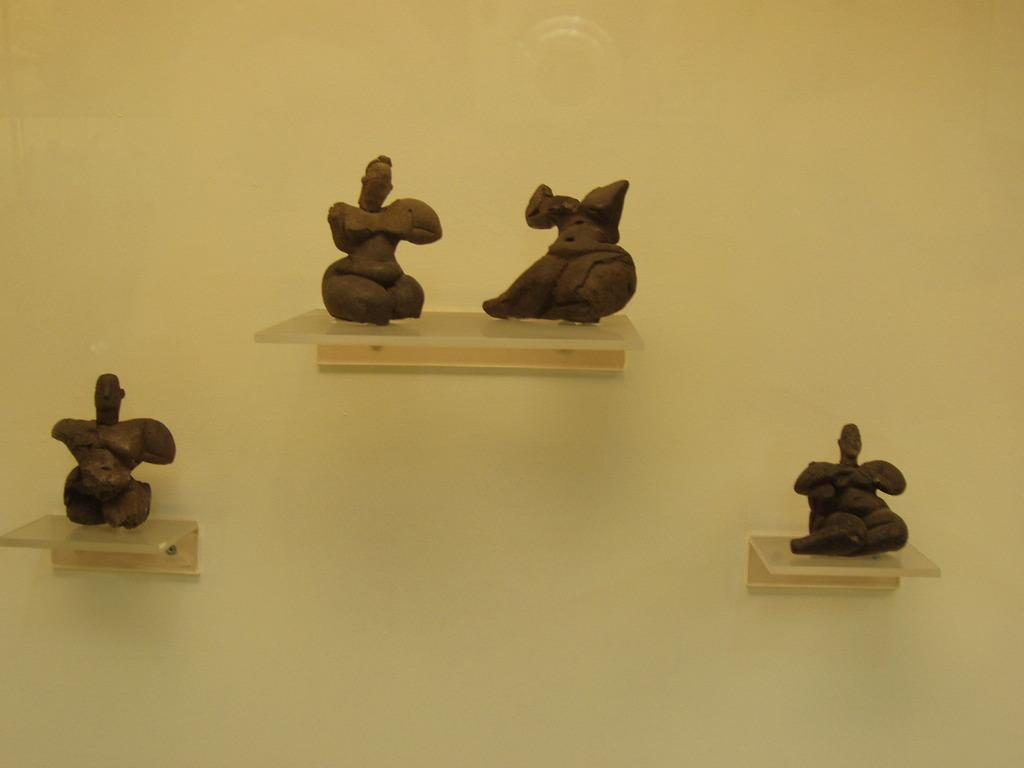What color is the wall in the image? There is a cream-colored wall in the image. What objects are attached to the wall? There are desks on the wall in the image. What is placed on the desks? There are sculptures on the desks in the image. What color are the sculptures? The sculptures are brown in color. How many zebras can be seen walking on the wall in the image? There are no zebras present in the image, and they cannot walk on the wall. 